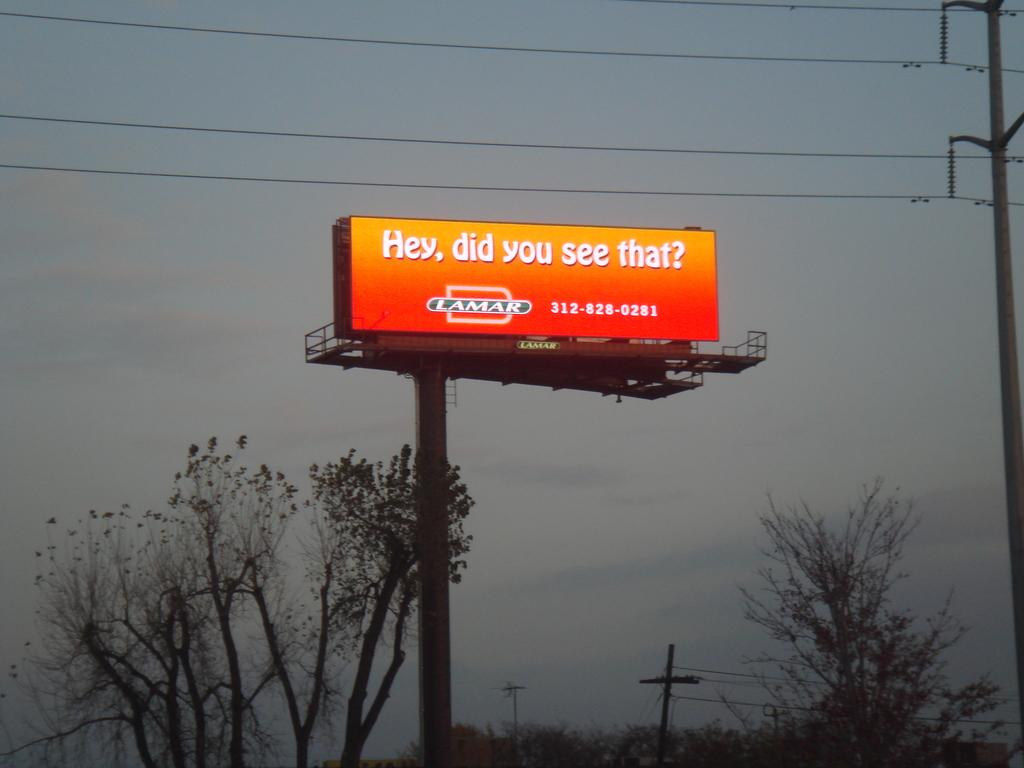<image>
Render a clear and concise summary of the photo. A billboard that says, "Hey did you see that?" 